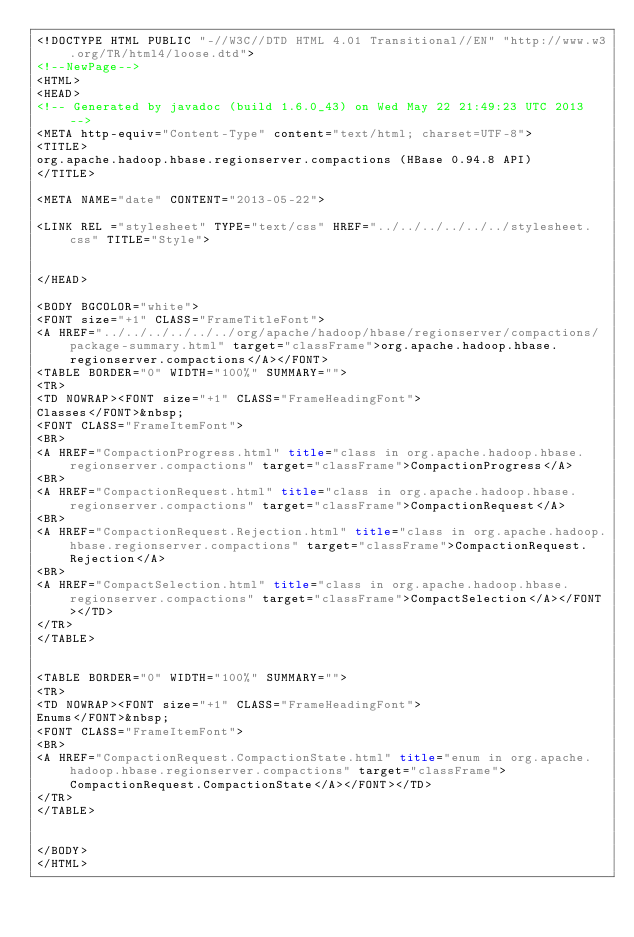Convert code to text. <code><loc_0><loc_0><loc_500><loc_500><_HTML_><!DOCTYPE HTML PUBLIC "-//W3C//DTD HTML 4.01 Transitional//EN" "http://www.w3.org/TR/html4/loose.dtd">
<!--NewPage-->
<HTML>
<HEAD>
<!-- Generated by javadoc (build 1.6.0_43) on Wed May 22 21:49:23 UTC 2013 -->
<META http-equiv="Content-Type" content="text/html; charset=UTF-8">
<TITLE>
org.apache.hadoop.hbase.regionserver.compactions (HBase 0.94.8 API)
</TITLE>

<META NAME="date" CONTENT="2013-05-22">

<LINK REL ="stylesheet" TYPE="text/css" HREF="../../../../../../stylesheet.css" TITLE="Style">


</HEAD>

<BODY BGCOLOR="white">
<FONT size="+1" CLASS="FrameTitleFont">
<A HREF="../../../../../../org/apache/hadoop/hbase/regionserver/compactions/package-summary.html" target="classFrame">org.apache.hadoop.hbase.regionserver.compactions</A></FONT>
<TABLE BORDER="0" WIDTH="100%" SUMMARY="">
<TR>
<TD NOWRAP><FONT size="+1" CLASS="FrameHeadingFont">
Classes</FONT>&nbsp;
<FONT CLASS="FrameItemFont">
<BR>
<A HREF="CompactionProgress.html" title="class in org.apache.hadoop.hbase.regionserver.compactions" target="classFrame">CompactionProgress</A>
<BR>
<A HREF="CompactionRequest.html" title="class in org.apache.hadoop.hbase.regionserver.compactions" target="classFrame">CompactionRequest</A>
<BR>
<A HREF="CompactionRequest.Rejection.html" title="class in org.apache.hadoop.hbase.regionserver.compactions" target="classFrame">CompactionRequest.Rejection</A>
<BR>
<A HREF="CompactSelection.html" title="class in org.apache.hadoop.hbase.regionserver.compactions" target="classFrame">CompactSelection</A></FONT></TD>
</TR>
</TABLE>


<TABLE BORDER="0" WIDTH="100%" SUMMARY="">
<TR>
<TD NOWRAP><FONT size="+1" CLASS="FrameHeadingFont">
Enums</FONT>&nbsp;
<FONT CLASS="FrameItemFont">
<BR>
<A HREF="CompactionRequest.CompactionState.html" title="enum in org.apache.hadoop.hbase.regionserver.compactions" target="classFrame">CompactionRequest.CompactionState</A></FONT></TD>
</TR>
</TABLE>


</BODY>
</HTML>
</code> 